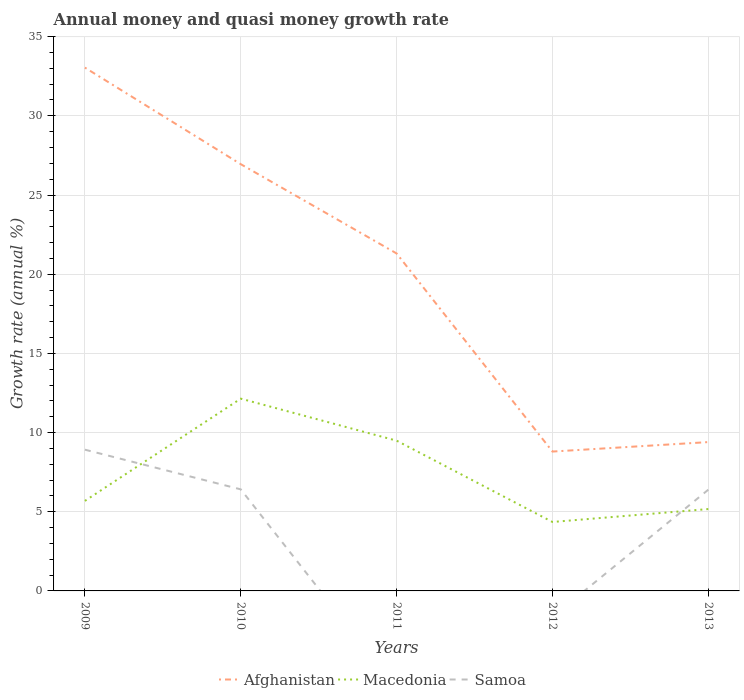Is the number of lines equal to the number of legend labels?
Offer a very short reply. No. Across all years, what is the maximum growth rate in Samoa?
Your answer should be very brief. 0. What is the total growth rate in Afghanistan in the graph?
Keep it short and to the point. 18.15. What is the difference between the highest and the second highest growth rate in Macedonia?
Make the answer very short. 7.79. What is the difference between the highest and the lowest growth rate in Samoa?
Offer a very short reply. 3. How many lines are there?
Provide a short and direct response. 3. Are the values on the major ticks of Y-axis written in scientific E-notation?
Provide a short and direct response. No. Does the graph contain any zero values?
Your answer should be very brief. Yes. Does the graph contain grids?
Offer a terse response. Yes. How many legend labels are there?
Your response must be concise. 3. What is the title of the graph?
Offer a very short reply. Annual money and quasi money growth rate. Does "Channel Islands" appear as one of the legend labels in the graph?
Ensure brevity in your answer.  No. What is the label or title of the Y-axis?
Your answer should be compact. Growth rate (annual %). What is the Growth rate (annual %) in Afghanistan in 2009?
Provide a succinct answer. 33.05. What is the Growth rate (annual %) of Macedonia in 2009?
Keep it short and to the point. 5.68. What is the Growth rate (annual %) of Samoa in 2009?
Provide a succinct answer. 8.92. What is the Growth rate (annual %) in Afghanistan in 2010?
Give a very brief answer. 26.95. What is the Growth rate (annual %) in Macedonia in 2010?
Your answer should be very brief. 12.14. What is the Growth rate (annual %) of Samoa in 2010?
Make the answer very short. 6.41. What is the Growth rate (annual %) of Afghanistan in 2011?
Give a very brief answer. 21.31. What is the Growth rate (annual %) in Macedonia in 2011?
Your answer should be very brief. 9.49. What is the Growth rate (annual %) in Afghanistan in 2012?
Provide a short and direct response. 8.8. What is the Growth rate (annual %) of Macedonia in 2012?
Offer a very short reply. 4.35. What is the Growth rate (annual %) of Samoa in 2012?
Keep it short and to the point. 0. What is the Growth rate (annual %) of Afghanistan in 2013?
Offer a very short reply. 9.4. What is the Growth rate (annual %) in Macedonia in 2013?
Offer a very short reply. 5.17. What is the Growth rate (annual %) in Samoa in 2013?
Provide a short and direct response. 6.39. Across all years, what is the maximum Growth rate (annual %) in Afghanistan?
Offer a very short reply. 33.05. Across all years, what is the maximum Growth rate (annual %) of Macedonia?
Make the answer very short. 12.14. Across all years, what is the maximum Growth rate (annual %) of Samoa?
Offer a terse response. 8.92. Across all years, what is the minimum Growth rate (annual %) in Afghanistan?
Ensure brevity in your answer.  8.8. Across all years, what is the minimum Growth rate (annual %) of Macedonia?
Provide a succinct answer. 4.35. Across all years, what is the minimum Growth rate (annual %) of Samoa?
Make the answer very short. 0. What is the total Growth rate (annual %) of Afghanistan in the graph?
Provide a short and direct response. 99.5. What is the total Growth rate (annual %) of Macedonia in the graph?
Your answer should be very brief. 36.84. What is the total Growth rate (annual %) of Samoa in the graph?
Your answer should be very brief. 21.73. What is the difference between the Growth rate (annual %) of Afghanistan in 2009 and that in 2010?
Your answer should be very brief. 6.1. What is the difference between the Growth rate (annual %) of Macedonia in 2009 and that in 2010?
Provide a succinct answer. -6.46. What is the difference between the Growth rate (annual %) in Samoa in 2009 and that in 2010?
Your answer should be very brief. 2.51. What is the difference between the Growth rate (annual %) in Afghanistan in 2009 and that in 2011?
Make the answer very short. 11.74. What is the difference between the Growth rate (annual %) in Macedonia in 2009 and that in 2011?
Give a very brief answer. -3.8. What is the difference between the Growth rate (annual %) of Afghanistan in 2009 and that in 2012?
Provide a short and direct response. 24.25. What is the difference between the Growth rate (annual %) of Macedonia in 2009 and that in 2012?
Keep it short and to the point. 1.33. What is the difference between the Growth rate (annual %) of Afghanistan in 2009 and that in 2013?
Your answer should be very brief. 23.65. What is the difference between the Growth rate (annual %) in Macedonia in 2009 and that in 2013?
Ensure brevity in your answer.  0.51. What is the difference between the Growth rate (annual %) of Samoa in 2009 and that in 2013?
Your answer should be compact. 2.53. What is the difference between the Growth rate (annual %) of Afghanistan in 2010 and that in 2011?
Your answer should be compact. 5.64. What is the difference between the Growth rate (annual %) of Macedonia in 2010 and that in 2011?
Provide a short and direct response. 2.65. What is the difference between the Growth rate (annual %) in Afghanistan in 2010 and that in 2012?
Make the answer very short. 18.15. What is the difference between the Growth rate (annual %) in Macedonia in 2010 and that in 2012?
Make the answer very short. 7.79. What is the difference between the Growth rate (annual %) of Afghanistan in 2010 and that in 2013?
Give a very brief answer. 17.55. What is the difference between the Growth rate (annual %) in Macedonia in 2010 and that in 2013?
Ensure brevity in your answer.  6.97. What is the difference between the Growth rate (annual %) in Samoa in 2010 and that in 2013?
Offer a very short reply. 0.02. What is the difference between the Growth rate (annual %) of Afghanistan in 2011 and that in 2012?
Your answer should be very brief. 12.51. What is the difference between the Growth rate (annual %) of Macedonia in 2011 and that in 2012?
Ensure brevity in your answer.  5.13. What is the difference between the Growth rate (annual %) in Afghanistan in 2011 and that in 2013?
Offer a terse response. 11.91. What is the difference between the Growth rate (annual %) in Macedonia in 2011 and that in 2013?
Keep it short and to the point. 4.32. What is the difference between the Growth rate (annual %) of Afghanistan in 2012 and that in 2013?
Ensure brevity in your answer.  -0.6. What is the difference between the Growth rate (annual %) in Macedonia in 2012 and that in 2013?
Provide a short and direct response. -0.82. What is the difference between the Growth rate (annual %) of Afghanistan in 2009 and the Growth rate (annual %) of Macedonia in 2010?
Give a very brief answer. 20.9. What is the difference between the Growth rate (annual %) of Afghanistan in 2009 and the Growth rate (annual %) of Samoa in 2010?
Give a very brief answer. 26.63. What is the difference between the Growth rate (annual %) in Macedonia in 2009 and the Growth rate (annual %) in Samoa in 2010?
Your answer should be compact. -0.73. What is the difference between the Growth rate (annual %) in Afghanistan in 2009 and the Growth rate (annual %) in Macedonia in 2011?
Ensure brevity in your answer.  23.56. What is the difference between the Growth rate (annual %) of Afghanistan in 2009 and the Growth rate (annual %) of Macedonia in 2012?
Offer a terse response. 28.69. What is the difference between the Growth rate (annual %) in Afghanistan in 2009 and the Growth rate (annual %) in Macedonia in 2013?
Keep it short and to the point. 27.88. What is the difference between the Growth rate (annual %) of Afghanistan in 2009 and the Growth rate (annual %) of Samoa in 2013?
Your response must be concise. 26.65. What is the difference between the Growth rate (annual %) in Macedonia in 2009 and the Growth rate (annual %) in Samoa in 2013?
Provide a short and direct response. -0.71. What is the difference between the Growth rate (annual %) in Afghanistan in 2010 and the Growth rate (annual %) in Macedonia in 2011?
Your response must be concise. 17.46. What is the difference between the Growth rate (annual %) of Afghanistan in 2010 and the Growth rate (annual %) of Macedonia in 2012?
Your answer should be compact. 22.59. What is the difference between the Growth rate (annual %) of Afghanistan in 2010 and the Growth rate (annual %) of Macedonia in 2013?
Provide a short and direct response. 21.78. What is the difference between the Growth rate (annual %) of Afghanistan in 2010 and the Growth rate (annual %) of Samoa in 2013?
Your answer should be very brief. 20.55. What is the difference between the Growth rate (annual %) of Macedonia in 2010 and the Growth rate (annual %) of Samoa in 2013?
Offer a terse response. 5.75. What is the difference between the Growth rate (annual %) in Afghanistan in 2011 and the Growth rate (annual %) in Macedonia in 2012?
Keep it short and to the point. 16.96. What is the difference between the Growth rate (annual %) in Afghanistan in 2011 and the Growth rate (annual %) in Macedonia in 2013?
Your answer should be compact. 16.14. What is the difference between the Growth rate (annual %) of Afghanistan in 2011 and the Growth rate (annual %) of Samoa in 2013?
Offer a terse response. 14.92. What is the difference between the Growth rate (annual %) in Macedonia in 2011 and the Growth rate (annual %) in Samoa in 2013?
Make the answer very short. 3.1. What is the difference between the Growth rate (annual %) in Afghanistan in 2012 and the Growth rate (annual %) in Macedonia in 2013?
Ensure brevity in your answer.  3.63. What is the difference between the Growth rate (annual %) in Afghanistan in 2012 and the Growth rate (annual %) in Samoa in 2013?
Your response must be concise. 2.41. What is the difference between the Growth rate (annual %) of Macedonia in 2012 and the Growth rate (annual %) of Samoa in 2013?
Your answer should be very brief. -2.04. What is the average Growth rate (annual %) of Afghanistan per year?
Offer a terse response. 19.9. What is the average Growth rate (annual %) in Macedonia per year?
Provide a succinct answer. 7.37. What is the average Growth rate (annual %) of Samoa per year?
Keep it short and to the point. 4.35. In the year 2009, what is the difference between the Growth rate (annual %) of Afghanistan and Growth rate (annual %) of Macedonia?
Provide a succinct answer. 27.36. In the year 2009, what is the difference between the Growth rate (annual %) of Afghanistan and Growth rate (annual %) of Samoa?
Give a very brief answer. 24.13. In the year 2009, what is the difference between the Growth rate (annual %) of Macedonia and Growth rate (annual %) of Samoa?
Ensure brevity in your answer.  -3.23. In the year 2010, what is the difference between the Growth rate (annual %) of Afghanistan and Growth rate (annual %) of Macedonia?
Provide a succinct answer. 14.81. In the year 2010, what is the difference between the Growth rate (annual %) of Afghanistan and Growth rate (annual %) of Samoa?
Offer a very short reply. 20.53. In the year 2010, what is the difference between the Growth rate (annual %) in Macedonia and Growth rate (annual %) in Samoa?
Provide a short and direct response. 5.73. In the year 2011, what is the difference between the Growth rate (annual %) of Afghanistan and Growth rate (annual %) of Macedonia?
Your answer should be very brief. 11.82. In the year 2012, what is the difference between the Growth rate (annual %) in Afghanistan and Growth rate (annual %) in Macedonia?
Ensure brevity in your answer.  4.45. In the year 2013, what is the difference between the Growth rate (annual %) of Afghanistan and Growth rate (annual %) of Macedonia?
Make the answer very short. 4.23. In the year 2013, what is the difference between the Growth rate (annual %) of Afghanistan and Growth rate (annual %) of Samoa?
Offer a terse response. 3.01. In the year 2013, what is the difference between the Growth rate (annual %) in Macedonia and Growth rate (annual %) in Samoa?
Provide a succinct answer. -1.22. What is the ratio of the Growth rate (annual %) of Afghanistan in 2009 to that in 2010?
Provide a succinct answer. 1.23. What is the ratio of the Growth rate (annual %) in Macedonia in 2009 to that in 2010?
Make the answer very short. 0.47. What is the ratio of the Growth rate (annual %) of Samoa in 2009 to that in 2010?
Your answer should be compact. 1.39. What is the ratio of the Growth rate (annual %) of Afghanistan in 2009 to that in 2011?
Ensure brevity in your answer.  1.55. What is the ratio of the Growth rate (annual %) in Macedonia in 2009 to that in 2011?
Provide a succinct answer. 0.6. What is the ratio of the Growth rate (annual %) of Afghanistan in 2009 to that in 2012?
Offer a terse response. 3.76. What is the ratio of the Growth rate (annual %) in Macedonia in 2009 to that in 2012?
Ensure brevity in your answer.  1.31. What is the ratio of the Growth rate (annual %) of Afghanistan in 2009 to that in 2013?
Ensure brevity in your answer.  3.52. What is the ratio of the Growth rate (annual %) of Macedonia in 2009 to that in 2013?
Ensure brevity in your answer.  1.1. What is the ratio of the Growth rate (annual %) of Samoa in 2009 to that in 2013?
Your response must be concise. 1.4. What is the ratio of the Growth rate (annual %) of Afghanistan in 2010 to that in 2011?
Give a very brief answer. 1.26. What is the ratio of the Growth rate (annual %) in Macedonia in 2010 to that in 2011?
Provide a succinct answer. 1.28. What is the ratio of the Growth rate (annual %) in Afghanistan in 2010 to that in 2012?
Ensure brevity in your answer.  3.06. What is the ratio of the Growth rate (annual %) in Macedonia in 2010 to that in 2012?
Offer a terse response. 2.79. What is the ratio of the Growth rate (annual %) of Afghanistan in 2010 to that in 2013?
Provide a succinct answer. 2.87. What is the ratio of the Growth rate (annual %) of Macedonia in 2010 to that in 2013?
Your response must be concise. 2.35. What is the ratio of the Growth rate (annual %) in Afghanistan in 2011 to that in 2012?
Offer a very short reply. 2.42. What is the ratio of the Growth rate (annual %) of Macedonia in 2011 to that in 2012?
Give a very brief answer. 2.18. What is the ratio of the Growth rate (annual %) of Afghanistan in 2011 to that in 2013?
Provide a succinct answer. 2.27. What is the ratio of the Growth rate (annual %) of Macedonia in 2011 to that in 2013?
Give a very brief answer. 1.84. What is the ratio of the Growth rate (annual %) in Afghanistan in 2012 to that in 2013?
Provide a succinct answer. 0.94. What is the ratio of the Growth rate (annual %) in Macedonia in 2012 to that in 2013?
Your response must be concise. 0.84. What is the difference between the highest and the second highest Growth rate (annual %) of Afghanistan?
Your answer should be very brief. 6.1. What is the difference between the highest and the second highest Growth rate (annual %) in Macedonia?
Your answer should be very brief. 2.65. What is the difference between the highest and the second highest Growth rate (annual %) of Samoa?
Ensure brevity in your answer.  2.51. What is the difference between the highest and the lowest Growth rate (annual %) of Afghanistan?
Keep it short and to the point. 24.25. What is the difference between the highest and the lowest Growth rate (annual %) in Macedonia?
Offer a terse response. 7.79. What is the difference between the highest and the lowest Growth rate (annual %) of Samoa?
Ensure brevity in your answer.  8.92. 